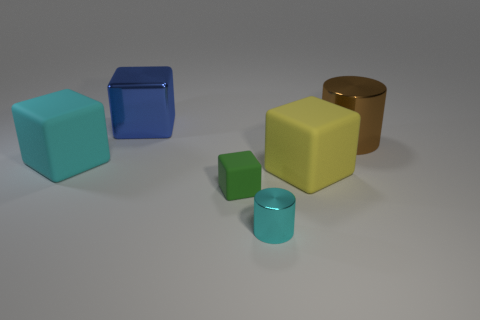Subtract all big blocks. How many blocks are left? 1 Add 2 rubber things. How many objects exist? 8 Subtract all cylinders. How many objects are left? 4 Subtract 2 cylinders. How many cylinders are left? 0 Subtract all brown cubes. How many cyan cylinders are left? 1 Subtract all big blue metal blocks. Subtract all small red metal cylinders. How many objects are left? 5 Add 6 brown objects. How many brown objects are left? 7 Add 5 purple blocks. How many purple blocks exist? 5 Subtract all cyan cylinders. How many cylinders are left? 1 Subtract 0 green cylinders. How many objects are left? 6 